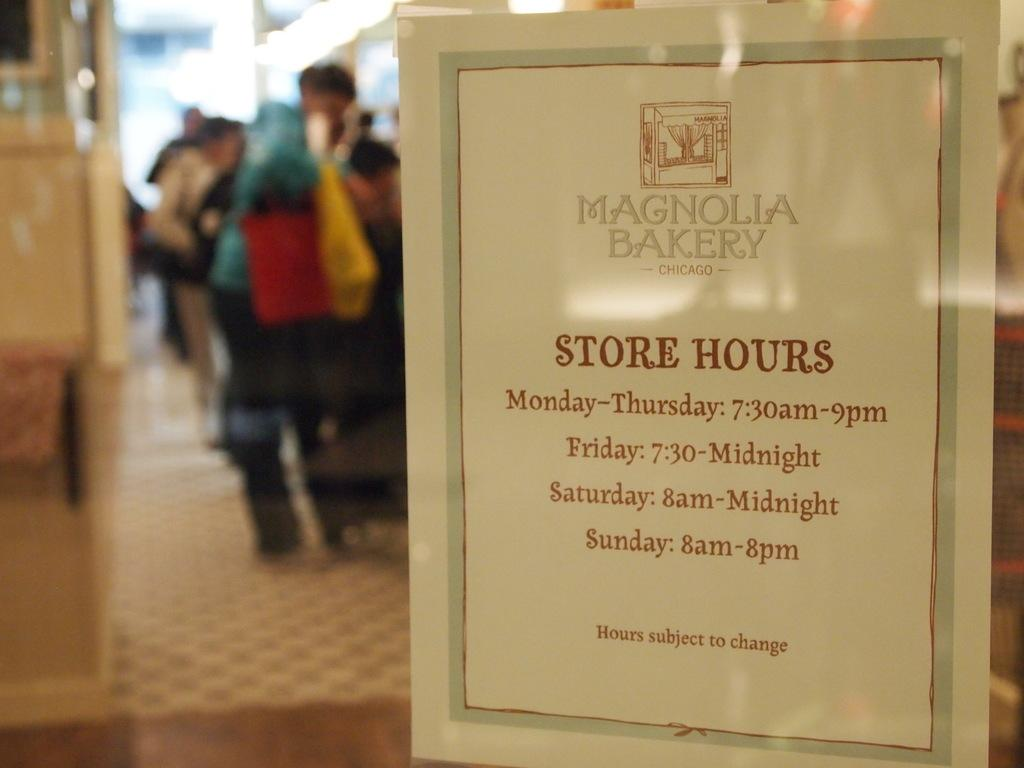Provide a one-sentence caption for the provided image. A PAPER DISPLAYED ON A STORE FRONT WINDOW THAT SHOW STORE HOURS. 